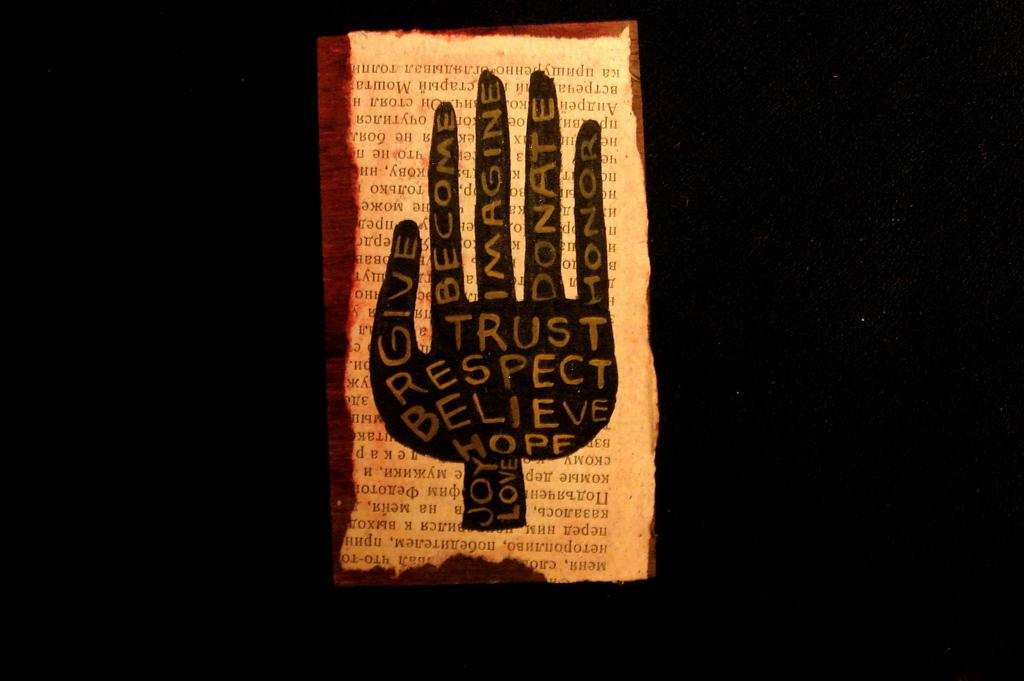What is the main object in the image? There is a paper in the image. What is depicted on the paper? The paper has a symbol of a hand on it. Are there any words or letters on the paper? Yes, there is text on the paper. How would you describe the overall appearance of the image? The background of the image is dark. Where is the basin located in the image? There is no basin present in the image. Is there a tub visible in the image? No, there is no tub visible in the image. 